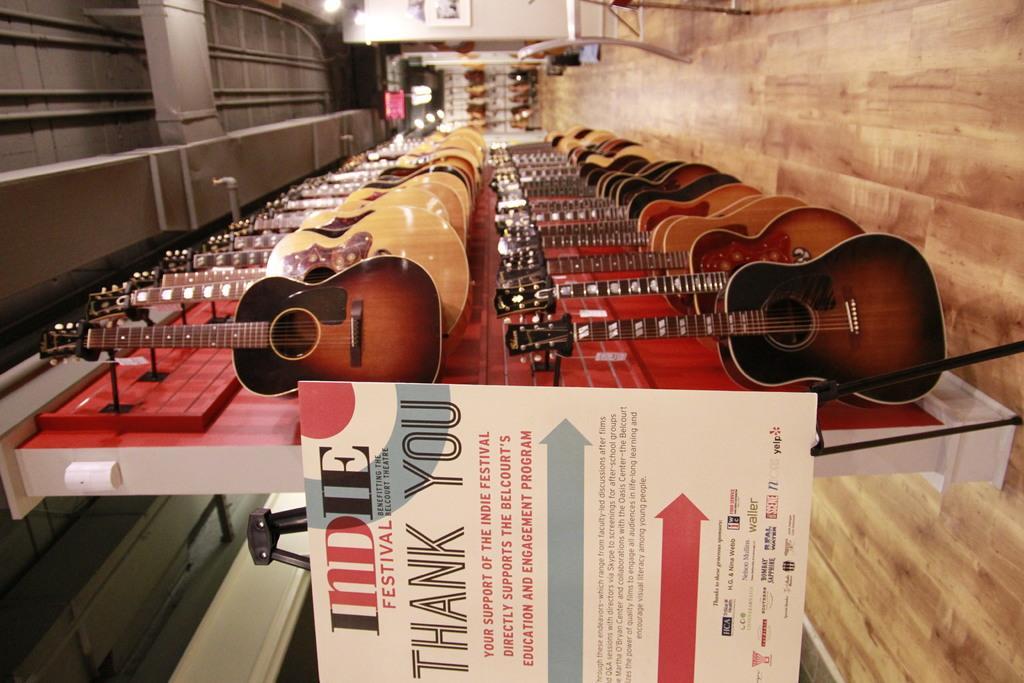How would you summarize this image in a sentence or two? In this image I can see a red colored board and to it I can see number of guitars which are cream, brown and black in color. I can see a white colored board attached to the surface. I can see the brown colored floor, the white colored wall, few lights and the ceiling. 